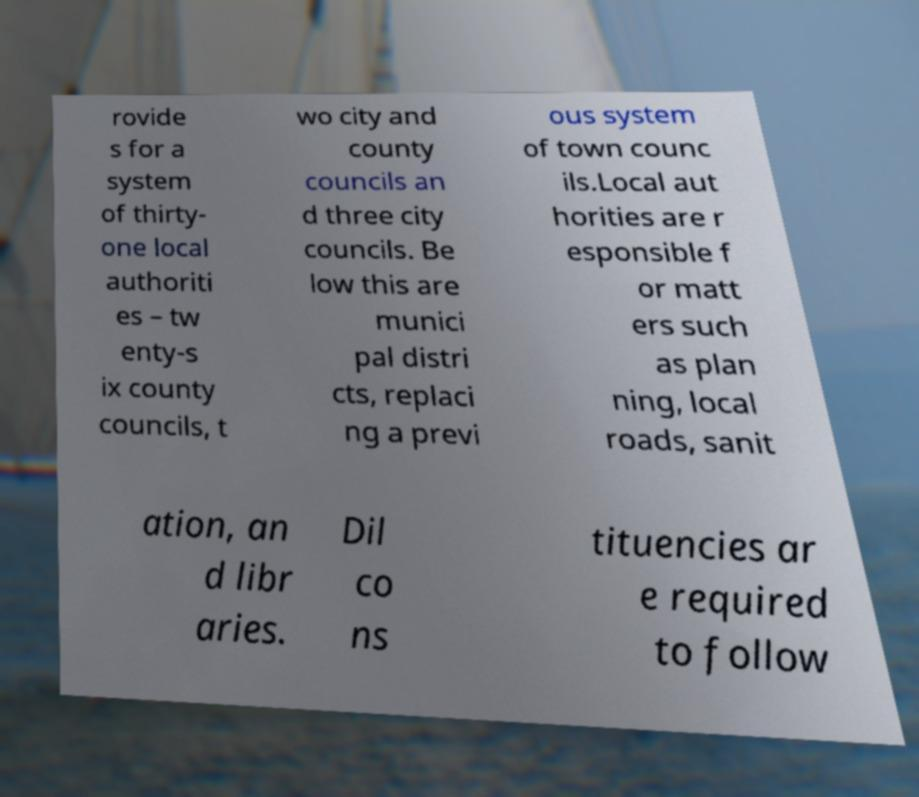I need the written content from this picture converted into text. Can you do that? rovide s for a system of thirty- one local authoriti es – tw enty-s ix county councils, t wo city and county councils an d three city councils. Be low this are munici pal distri cts, replaci ng a previ ous system of town counc ils.Local aut horities are r esponsible f or matt ers such as plan ning, local roads, sanit ation, an d libr aries. Dil co ns tituencies ar e required to follow 